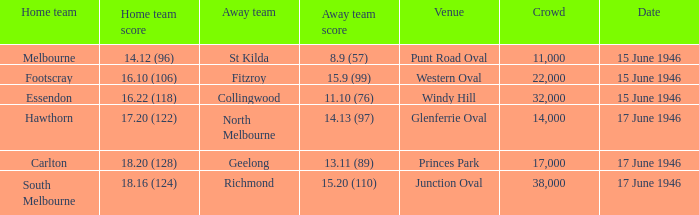Which home team has a home team 14.12 (96)? Melbourne. 